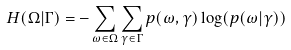<formula> <loc_0><loc_0><loc_500><loc_500>H ( \Omega | \Gamma ) = - \sum _ { \omega \in \Omega } \sum _ { \gamma \in \Gamma } p ( \omega , \gamma ) \log ( p ( \omega | \gamma ) )</formula> 